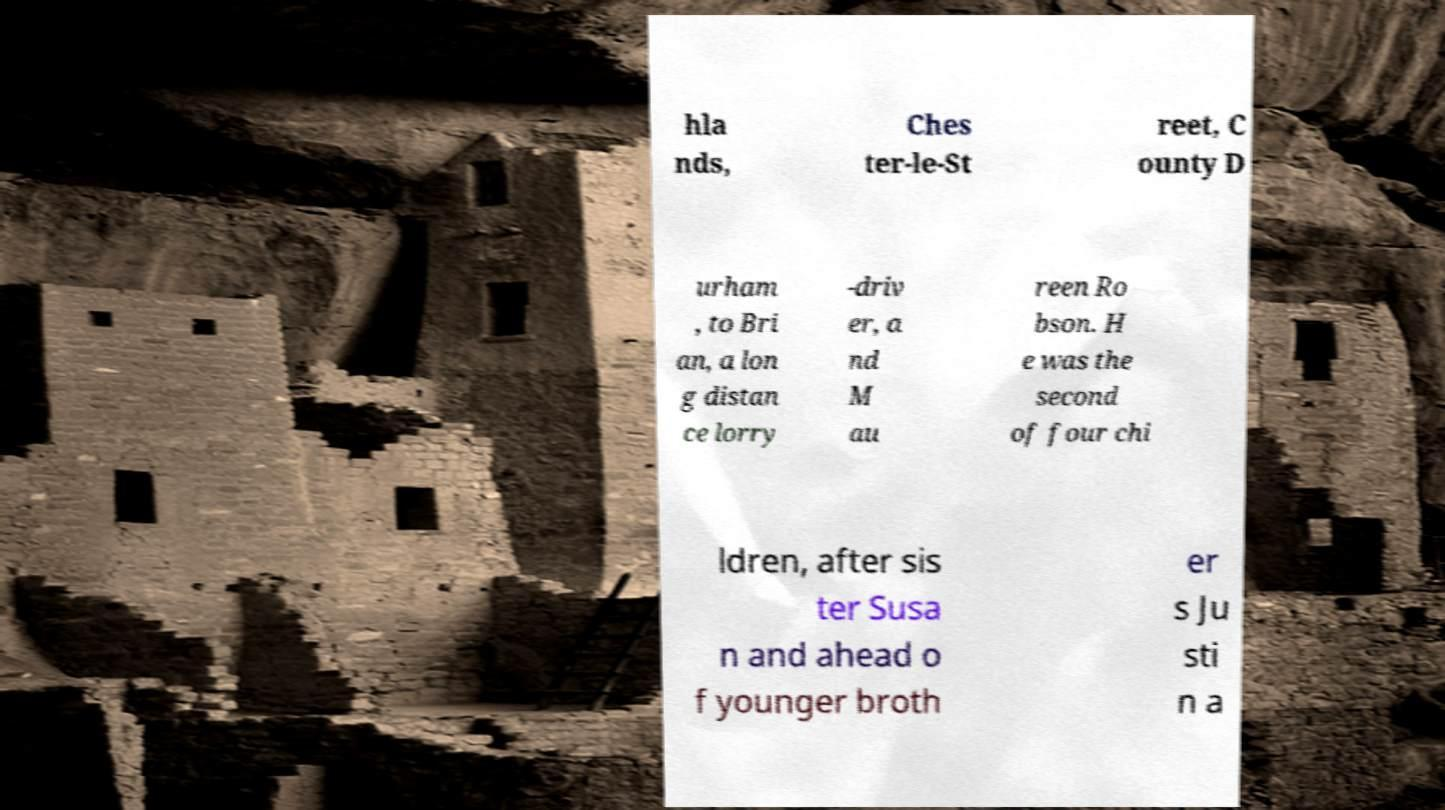Could you assist in decoding the text presented in this image and type it out clearly? hla nds, Ches ter-le-St reet, C ounty D urham , to Bri an, a lon g distan ce lorry -driv er, a nd M au reen Ro bson. H e was the second of four chi ldren, after sis ter Susa n and ahead o f younger broth er s Ju sti n a 